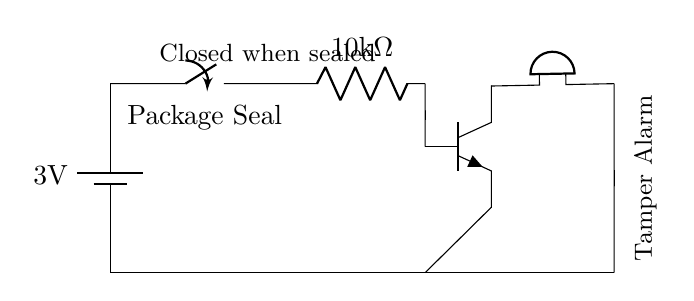What is the voltage of the battery? The circuit shows a battery labeled with a voltage of 3 volts. This voltage is the electrical potential difference provided by the battery to the circuit.
Answer: 3 volts What type of switch is used in this circuit? The switch is labeled as a "Package Seal." This indicates that it is a specific type of switch that is normally closed and will open when the package is tampered with.
Answer: Package Seal What is the resistance value of the resistor? The circuit diagram displays a resistor labeled with a resistance of 10 kilohms. This indicates the opposition to current flow within the circuit.
Answer: 10 kilohms How does the alarm activate? The alarm activates when the switch is opened, leading to current flow through the transistor and energizing the buzzer. When the package is sealed, the switch remains closed, and the alarm remains inactive.
Answer: Current flow through the transistor What component is used to indicate tampering? The component specifically designed to indicate tampering is the buzzer, which will sound an alarm when it receives current from the completed circuit.
Answer: Buzzer What type of transistor is used in the circuit? The circuit includes an NPN transistor, as indicated by the npn notation next to the transistor symbol. NPN transistors are typically used in low power applications for switching.
Answer: NPN 